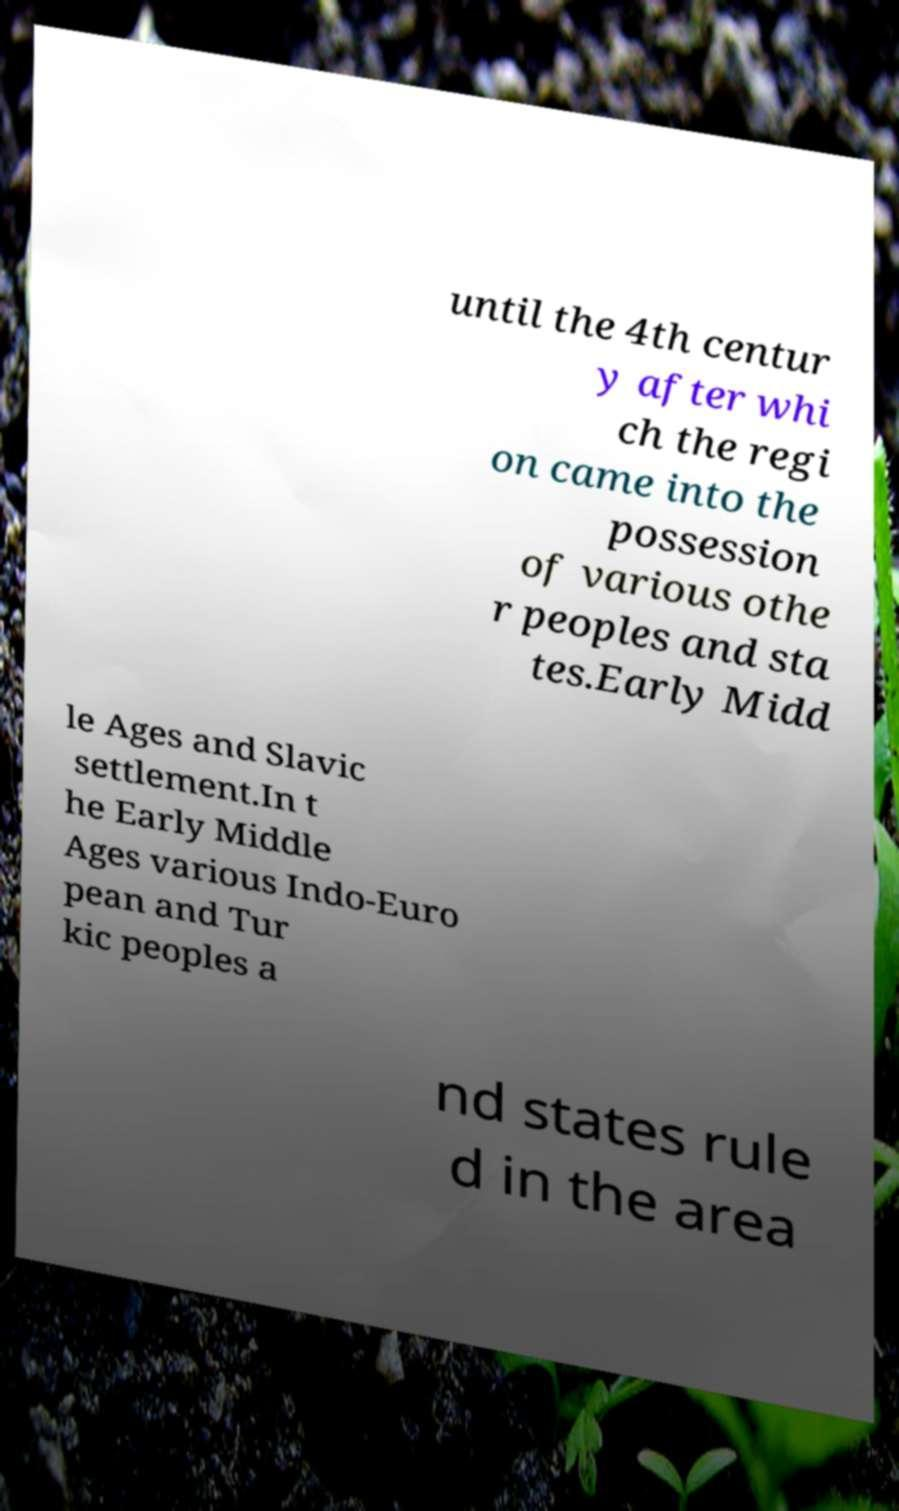Please read and relay the text visible in this image. What does it say? until the 4th centur y after whi ch the regi on came into the possession of various othe r peoples and sta tes.Early Midd le Ages and Slavic settlement.In t he Early Middle Ages various Indo-Euro pean and Tur kic peoples a nd states rule d in the area 